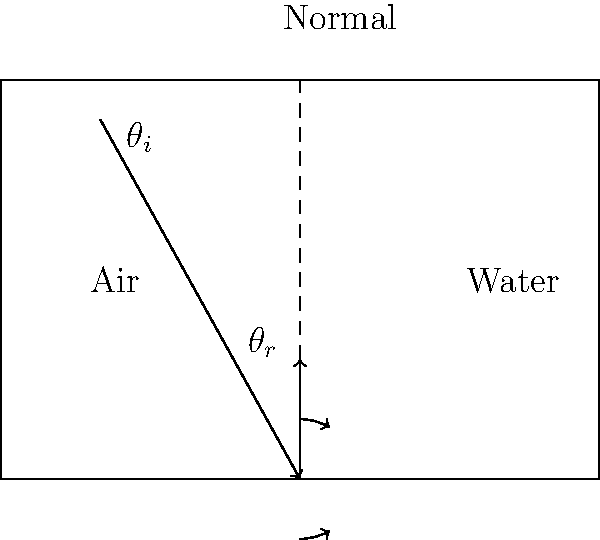A beam of light passes from air into water, as shown in the diagram. Given that the refractive index of air is 1.00 and the refractive index of water is 1.33, calculate the angle of refraction ($\theta_r$) if the angle of incidence ($\theta_i$) is 30°. How does this demonstrate the principle that context is crucial in understanding physical phenomena? To solve this problem and understand its context, let's follow these steps:

1) Recall Snell's Law: $n_1 \sin(\theta_1) = n_2 \sin(\theta_2)$, where $n_1$ and $n_2$ are the refractive indices of the two media, and $\theta_1$ and $\theta_2$ are the angles of incidence and refraction, respectively.

2) In this case:
   $n_1 = 1.00$ (air)
   $n_2 = 1.33$ (water)
   $\theta_1 = \theta_i = 30°$
   $\theta_2 = \theta_r$ (what we're solving for)

3) Plug these values into Snell's Law:
   $1.00 \sin(30°) = 1.33 \sin(\theta_r)$

4) Simplify the left side:
   $0.5 = 1.33 \sin(\theta_r)$

5) Solve for $\sin(\theta_r)$:
   $\sin(\theta_r) = \frac{0.5}{1.33} \approx 0.3759$

6) Take the inverse sine (arcsin) of both sides:
   $\theta_r = \arcsin(0.3759) \approx 22.1°$

This problem demonstrates the importance of context in several ways:

1) The behavior of light changes depending on the medium it's traveling through, illustrating how physical phenomena are context-dependent.

2) The refractive indices provide crucial context for understanding and predicting the light's behavior.

3) The angle of refraction is smaller than the angle of incidence when light moves from a less dense to a more dense medium, showing how context affects outcomes.

4) This principle has wide-ranging applications, from fiber optics to the appearance of objects underwater, demonstrating how understanding context can lead to practical applications and deeper insights in various fields.
Answer: $22.1°$ 